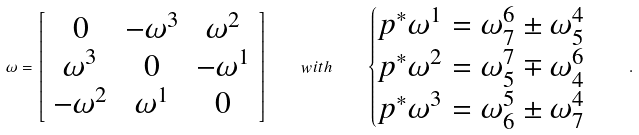<formula> <loc_0><loc_0><loc_500><loc_500>\omega = \left [ \begin{array} { c c c } 0 & - \omega ^ { 3 } & \omega ^ { 2 } \\ \omega ^ { 3 } & 0 & - \omega ^ { 1 } \\ - \omega ^ { 2 } & \omega ^ { 1 } & 0 \end{array} \right ] \quad w i t h \quad \begin{cases} p ^ { * } \omega ^ { 1 } = \omega ^ { 6 } _ { 7 } \pm \omega ^ { 4 } _ { 5 } \\ p ^ { * } \omega ^ { 2 } = \omega ^ { 7 } _ { 5 } \mp \omega ^ { 6 } _ { 4 } \\ p ^ { * } \omega ^ { 3 } = \omega ^ { 5 } _ { 6 } \pm \omega ^ { 4 } _ { 7 } \end{cases} \ .</formula> 